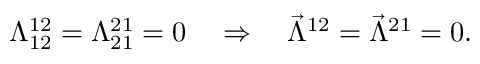<formula> <loc_0><loc_0><loc_500><loc_500>\Lambda _ { 1 2 } ^ { 1 2 } = \Lambda _ { 2 1 } ^ { 2 1 } = 0 \quad \Rightarrow \quad \vec { \Lambda } ^ { 1 2 } = \vec { \Lambda } ^ { 2 1 } = 0 .</formula> 